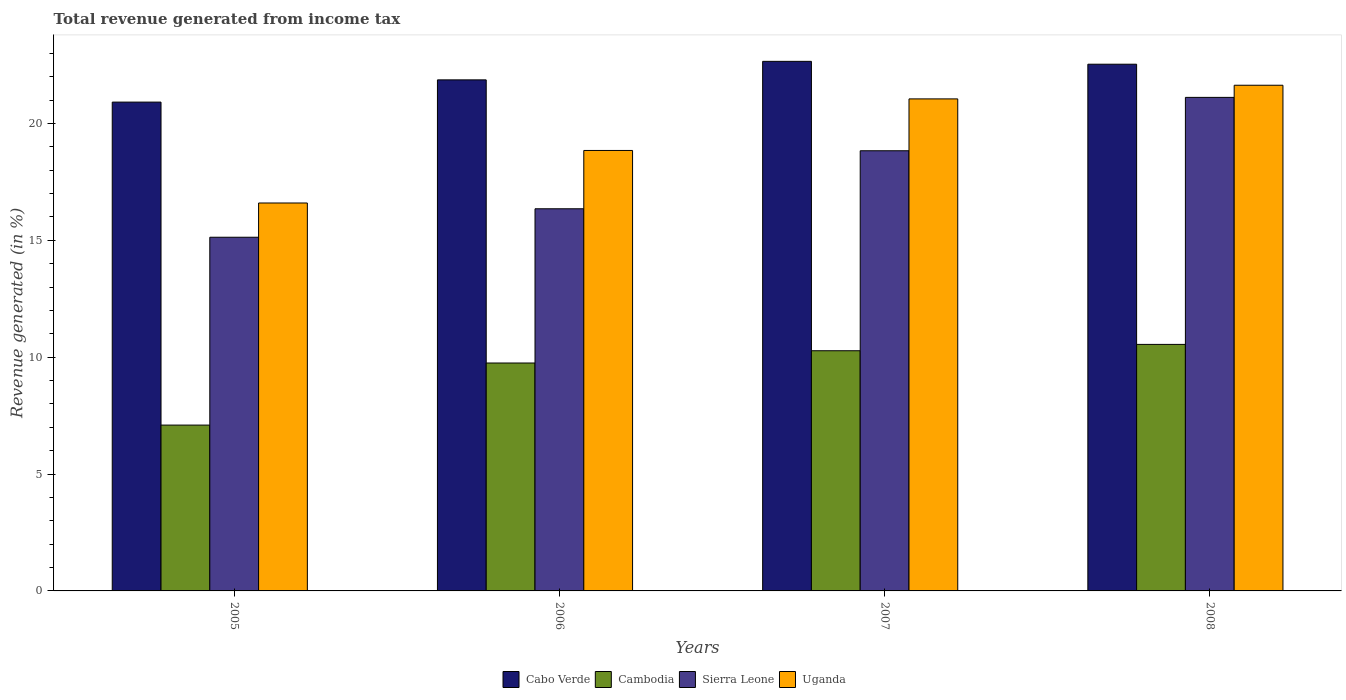How many different coloured bars are there?
Provide a succinct answer. 4. How many groups of bars are there?
Ensure brevity in your answer.  4. Are the number of bars per tick equal to the number of legend labels?
Your answer should be very brief. Yes. How many bars are there on the 1st tick from the right?
Provide a short and direct response. 4. What is the label of the 3rd group of bars from the left?
Make the answer very short. 2007. What is the total revenue generated in Uganda in 2008?
Provide a succinct answer. 21.63. Across all years, what is the maximum total revenue generated in Uganda?
Provide a short and direct response. 21.63. Across all years, what is the minimum total revenue generated in Sierra Leone?
Offer a very short reply. 15.13. What is the total total revenue generated in Cambodia in the graph?
Your answer should be compact. 37.67. What is the difference between the total revenue generated in Cambodia in 2005 and that in 2007?
Your answer should be compact. -3.18. What is the difference between the total revenue generated in Cambodia in 2008 and the total revenue generated in Sierra Leone in 2005?
Offer a very short reply. -4.58. What is the average total revenue generated in Uganda per year?
Ensure brevity in your answer.  19.53. In the year 2007, what is the difference between the total revenue generated in Uganda and total revenue generated in Cabo Verde?
Give a very brief answer. -1.61. In how many years, is the total revenue generated in Cabo Verde greater than 22 %?
Keep it short and to the point. 2. What is the ratio of the total revenue generated in Cabo Verde in 2007 to that in 2008?
Keep it short and to the point. 1.01. Is the total revenue generated in Sierra Leone in 2005 less than that in 2008?
Make the answer very short. Yes. What is the difference between the highest and the second highest total revenue generated in Cabo Verde?
Ensure brevity in your answer.  0.12. What is the difference between the highest and the lowest total revenue generated in Sierra Leone?
Your answer should be very brief. 5.98. In how many years, is the total revenue generated in Cabo Verde greater than the average total revenue generated in Cabo Verde taken over all years?
Ensure brevity in your answer.  2. Is it the case that in every year, the sum of the total revenue generated in Sierra Leone and total revenue generated in Cambodia is greater than the sum of total revenue generated in Cabo Verde and total revenue generated in Uganda?
Keep it short and to the point. No. What does the 1st bar from the left in 2005 represents?
Make the answer very short. Cabo Verde. What does the 2nd bar from the right in 2007 represents?
Give a very brief answer. Sierra Leone. How many years are there in the graph?
Give a very brief answer. 4. What is the difference between two consecutive major ticks on the Y-axis?
Make the answer very short. 5. Where does the legend appear in the graph?
Offer a terse response. Bottom center. How many legend labels are there?
Your answer should be compact. 4. How are the legend labels stacked?
Offer a very short reply. Horizontal. What is the title of the graph?
Offer a terse response. Total revenue generated from income tax. What is the label or title of the X-axis?
Give a very brief answer. Years. What is the label or title of the Y-axis?
Your answer should be compact. Revenue generated (in %). What is the Revenue generated (in %) of Cabo Verde in 2005?
Your response must be concise. 20.91. What is the Revenue generated (in %) in Cambodia in 2005?
Provide a short and direct response. 7.09. What is the Revenue generated (in %) of Sierra Leone in 2005?
Your answer should be compact. 15.13. What is the Revenue generated (in %) in Uganda in 2005?
Offer a very short reply. 16.6. What is the Revenue generated (in %) of Cabo Verde in 2006?
Keep it short and to the point. 21.86. What is the Revenue generated (in %) of Cambodia in 2006?
Offer a very short reply. 9.75. What is the Revenue generated (in %) of Sierra Leone in 2006?
Your response must be concise. 16.35. What is the Revenue generated (in %) of Uganda in 2006?
Keep it short and to the point. 18.84. What is the Revenue generated (in %) of Cabo Verde in 2007?
Offer a terse response. 22.66. What is the Revenue generated (in %) of Cambodia in 2007?
Offer a terse response. 10.28. What is the Revenue generated (in %) in Sierra Leone in 2007?
Give a very brief answer. 18.83. What is the Revenue generated (in %) in Uganda in 2007?
Ensure brevity in your answer.  21.05. What is the Revenue generated (in %) in Cabo Verde in 2008?
Offer a very short reply. 22.53. What is the Revenue generated (in %) in Cambodia in 2008?
Ensure brevity in your answer.  10.55. What is the Revenue generated (in %) of Sierra Leone in 2008?
Your answer should be compact. 21.11. What is the Revenue generated (in %) of Uganda in 2008?
Your answer should be very brief. 21.63. Across all years, what is the maximum Revenue generated (in %) in Cabo Verde?
Ensure brevity in your answer.  22.66. Across all years, what is the maximum Revenue generated (in %) of Cambodia?
Offer a terse response. 10.55. Across all years, what is the maximum Revenue generated (in %) in Sierra Leone?
Offer a terse response. 21.11. Across all years, what is the maximum Revenue generated (in %) in Uganda?
Offer a terse response. 21.63. Across all years, what is the minimum Revenue generated (in %) in Cabo Verde?
Provide a short and direct response. 20.91. Across all years, what is the minimum Revenue generated (in %) of Cambodia?
Ensure brevity in your answer.  7.09. Across all years, what is the minimum Revenue generated (in %) of Sierra Leone?
Ensure brevity in your answer.  15.13. Across all years, what is the minimum Revenue generated (in %) in Uganda?
Ensure brevity in your answer.  16.6. What is the total Revenue generated (in %) in Cabo Verde in the graph?
Ensure brevity in your answer.  87.97. What is the total Revenue generated (in %) in Cambodia in the graph?
Offer a terse response. 37.67. What is the total Revenue generated (in %) of Sierra Leone in the graph?
Your response must be concise. 71.43. What is the total Revenue generated (in %) of Uganda in the graph?
Provide a succinct answer. 78.12. What is the difference between the Revenue generated (in %) in Cabo Verde in 2005 and that in 2006?
Your answer should be compact. -0.95. What is the difference between the Revenue generated (in %) in Cambodia in 2005 and that in 2006?
Ensure brevity in your answer.  -2.66. What is the difference between the Revenue generated (in %) in Sierra Leone in 2005 and that in 2006?
Your answer should be compact. -1.22. What is the difference between the Revenue generated (in %) of Uganda in 2005 and that in 2006?
Provide a succinct answer. -2.25. What is the difference between the Revenue generated (in %) in Cabo Verde in 2005 and that in 2007?
Provide a succinct answer. -1.74. What is the difference between the Revenue generated (in %) of Cambodia in 2005 and that in 2007?
Make the answer very short. -3.18. What is the difference between the Revenue generated (in %) of Sierra Leone in 2005 and that in 2007?
Your answer should be very brief. -3.7. What is the difference between the Revenue generated (in %) in Uganda in 2005 and that in 2007?
Provide a succinct answer. -4.45. What is the difference between the Revenue generated (in %) of Cabo Verde in 2005 and that in 2008?
Your answer should be very brief. -1.62. What is the difference between the Revenue generated (in %) in Cambodia in 2005 and that in 2008?
Provide a succinct answer. -3.45. What is the difference between the Revenue generated (in %) of Sierra Leone in 2005 and that in 2008?
Keep it short and to the point. -5.98. What is the difference between the Revenue generated (in %) in Uganda in 2005 and that in 2008?
Give a very brief answer. -5.04. What is the difference between the Revenue generated (in %) of Cabo Verde in 2006 and that in 2007?
Offer a terse response. -0.79. What is the difference between the Revenue generated (in %) of Cambodia in 2006 and that in 2007?
Ensure brevity in your answer.  -0.52. What is the difference between the Revenue generated (in %) in Sierra Leone in 2006 and that in 2007?
Your answer should be compact. -2.48. What is the difference between the Revenue generated (in %) of Uganda in 2006 and that in 2007?
Your answer should be compact. -2.21. What is the difference between the Revenue generated (in %) of Cabo Verde in 2006 and that in 2008?
Your answer should be very brief. -0.67. What is the difference between the Revenue generated (in %) in Cambodia in 2006 and that in 2008?
Your answer should be very brief. -0.8. What is the difference between the Revenue generated (in %) in Sierra Leone in 2006 and that in 2008?
Provide a succinct answer. -4.77. What is the difference between the Revenue generated (in %) of Uganda in 2006 and that in 2008?
Your answer should be very brief. -2.79. What is the difference between the Revenue generated (in %) in Cabo Verde in 2007 and that in 2008?
Give a very brief answer. 0.12. What is the difference between the Revenue generated (in %) in Cambodia in 2007 and that in 2008?
Your response must be concise. -0.27. What is the difference between the Revenue generated (in %) of Sierra Leone in 2007 and that in 2008?
Provide a short and direct response. -2.28. What is the difference between the Revenue generated (in %) of Uganda in 2007 and that in 2008?
Provide a short and direct response. -0.58. What is the difference between the Revenue generated (in %) of Cabo Verde in 2005 and the Revenue generated (in %) of Cambodia in 2006?
Your answer should be very brief. 11.16. What is the difference between the Revenue generated (in %) in Cabo Verde in 2005 and the Revenue generated (in %) in Sierra Leone in 2006?
Provide a succinct answer. 4.56. What is the difference between the Revenue generated (in %) of Cabo Verde in 2005 and the Revenue generated (in %) of Uganda in 2006?
Provide a short and direct response. 2.07. What is the difference between the Revenue generated (in %) in Cambodia in 2005 and the Revenue generated (in %) in Sierra Leone in 2006?
Offer a terse response. -9.25. What is the difference between the Revenue generated (in %) in Cambodia in 2005 and the Revenue generated (in %) in Uganda in 2006?
Your answer should be compact. -11.75. What is the difference between the Revenue generated (in %) of Sierra Leone in 2005 and the Revenue generated (in %) of Uganda in 2006?
Ensure brevity in your answer.  -3.71. What is the difference between the Revenue generated (in %) in Cabo Verde in 2005 and the Revenue generated (in %) in Cambodia in 2007?
Provide a succinct answer. 10.64. What is the difference between the Revenue generated (in %) in Cabo Verde in 2005 and the Revenue generated (in %) in Sierra Leone in 2007?
Provide a short and direct response. 2.08. What is the difference between the Revenue generated (in %) in Cabo Verde in 2005 and the Revenue generated (in %) in Uganda in 2007?
Give a very brief answer. -0.14. What is the difference between the Revenue generated (in %) of Cambodia in 2005 and the Revenue generated (in %) of Sierra Leone in 2007?
Ensure brevity in your answer.  -11.74. What is the difference between the Revenue generated (in %) in Cambodia in 2005 and the Revenue generated (in %) in Uganda in 2007?
Give a very brief answer. -13.96. What is the difference between the Revenue generated (in %) in Sierra Leone in 2005 and the Revenue generated (in %) in Uganda in 2007?
Your answer should be compact. -5.92. What is the difference between the Revenue generated (in %) in Cabo Verde in 2005 and the Revenue generated (in %) in Cambodia in 2008?
Give a very brief answer. 10.37. What is the difference between the Revenue generated (in %) of Cabo Verde in 2005 and the Revenue generated (in %) of Sierra Leone in 2008?
Keep it short and to the point. -0.2. What is the difference between the Revenue generated (in %) in Cabo Verde in 2005 and the Revenue generated (in %) in Uganda in 2008?
Your answer should be very brief. -0.72. What is the difference between the Revenue generated (in %) in Cambodia in 2005 and the Revenue generated (in %) in Sierra Leone in 2008?
Keep it short and to the point. -14.02. What is the difference between the Revenue generated (in %) in Cambodia in 2005 and the Revenue generated (in %) in Uganda in 2008?
Provide a succinct answer. -14.54. What is the difference between the Revenue generated (in %) in Sierra Leone in 2005 and the Revenue generated (in %) in Uganda in 2008?
Your response must be concise. -6.5. What is the difference between the Revenue generated (in %) of Cabo Verde in 2006 and the Revenue generated (in %) of Cambodia in 2007?
Provide a short and direct response. 11.59. What is the difference between the Revenue generated (in %) of Cabo Verde in 2006 and the Revenue generated (in %) of Sierra Leone in 2007?
Keep it short and to the point. 3.03. What is the difference between the Revenue generated (in %) of Cabo Verde in 2006 and the Revenue generated (in %) of Uganda in 2007?
Provide a short and direct response. 0.81. What is the difference between the Revenue generated (in %) in Cambodia in 2006 and the Revenue generated (in %) in Sierra Leone in 2007?
Ensure brevity in your answer.  -9.08. What is the difference between the Revenue generated (in %) of Cambodia in 2006 and the Revenue generated (in %) of Uganda in 2007?
Make the answer very short. -11.3. What is the difference between the Revenue generated (in %) of Sierra Leone in 2006 and the Revenue generated (in %) of Uganda in 2007?
Provide a succinct answer. -4.7. What is the difference between the Revenue generated (in %) in Cabo Verde in 2006 and the Revenue generated (in %) in Cambodia in 2008?
Your response must be concise. 11.32. What is the difference between the Revenue generated (in %) of Cabo Verde in 2006 and the Revenue generated (in %) of Sierra Leone in 2008?
Give a very brief answer. 0.75. What is the difference between the Revenue generated (in %) in Cabo Verde in 2006 and the Revenue generated (in %) in Uganda in 2008?
Provide a succinct answer. 0.23. What is the difference between the Revenue generated (in %) in Cambodia in 2006 and the Revenue generated (in %) in Sierra Leone in 2008?
Your answer should be compact. -11.36. What is the difference between the Revenue generated (in %) in Cambodia in 2006 and the Revenue generated (in %) in Uganda in 2008?
Offer a very short reply. -11.88. What is the difference between the Revenue generated (in %) in Sierra Leone in 2006 and the Revenue generated (in %) in Uganda in 2008?
Provide a short and direct response. -5.28. What is the difference between the Revenue generated (in %) in Cabo Verde in 2007 and the Revenue generated (in %) in Cambodia in 2008?
Give a very brief answer. 12.11. What is the difference between the Revenue generated (in %) in Cabo Verde in 2007 and the Revenue generated (in %) in Sierra Leone in 2008?
Ensure brevity in your answer.  1.54. What is the difference between the Revenue generated (in %) in Cabo Verde in 2007 and the Revenue generated (in %) in Uganda in 2008?
Give a very brief answer. 1.02. What is the difference between the Revenue generated (in %) in Cambodia in 2007 and the Revenue generated (in %) in Sierra Leone in 2008?
Provide a succinct answer. -10.84. What is the difference between the Revenue generated (in %) of Cambodia in 2007 and the Revenue generated (in %) of Uganda in 2008?
Your answer should be very brief. -11.36. What is the difference between the Revenue generated (in %) of Sierra Leone in 2007 and the Revenue generated (in %) of Uganda in 2008?
Make the answer very short. -2.8. What is the average Revenue generated (in %) in Cabo Verde per year?
Keep it short and to the point. 21.99. What is the average Revenue generated (in %) of Cambodia per year?
Ensure brevity in your answer.  9.42. What is the average Revenue generated (in %) in Sierra Leone per year?
Give a very brief answer. 17.86. What is the average Revenue generated (in %) in Uganda per year?
Keep it short and to the point. 19.53. In the year 2005, what is the difference between the Revenue generated (in %) in Cabo Verde and Revenue generated (in %) in Cambodia?
Offer a terse response. 13.82. In the year 2005, what is the difference between the Revenue generated (in %) in Cabo Verde and Revenue generated (in %) in Sierra Leone?
Give a very brief answer. 5.78. In the year 2005, what is the difference between the Revenue generated (in %) of Cabo Verde and Revenue generated (in %) of Uganda?
Give a very brief answer. 4.32. In the year 2005, what is the difference between the Revenue generated (in %) in Cambodia and Revenue generated (in %) in Sierra Leone?
Your answer should be very brief. -8.04. In the year 2005, what is the difference between the Revenue generated (in %) in Cambodia and Revenue generated (in %) in Uganda?
Give a very brief answer. -9.5. In the year 2005, what is the difference between the Revenue generated (in %) in Sierra Leone and Revenue generated (in %) in Uganda?
Your response must be concise. -1.46. In the year 2006, what is the difference between the Revenue generated (in %) in Cabo Verde and Revenue generated (in %) in Cambodia?
Provide a short and direct response. 12.11. In the year 2006, what is the difference between the Revenue generated (in %) of Cabo Verde and Revenue generated (in %) of Sierra Leone?
Your answer should be very brief. 5.51. In the year 2006, what is the difference between the Revenue generated (in %) in Cabo Verde and Revenue generated (in %) in Uganda?
Your answer should be very brief. 3.02. In the year 2006, what is the difference between the Revenue generated (in %) of Cambodia and Revenue generated (in %) of Sierra Leone?
Keep it short and to the point. -6.6. In the year 2006, what is the difference between the Revenue generated (in %) of Cambodia and Revenue generated (in %) of Uganda?
Keep it short and to the point. -9.09. In the year 2006, what is the difference between the Revenue generated (in %) of Sierra Leone and Revenue generated (in %) of Uganda?
Offer a terse response. -2.49. In the year 2007, what is the difference between the Revenue generated (in %) in Cabo Verde and Revenue generated (in %) in Cambodia?
Offer a very short reply. 12.38. In the year 2007, what is the difference between the Revenue generated (in %) in Cabo Verde and Revenue generated (in %) in Sierra Leone?
Offer a terse response. 3.83. In the year 2007, what is the difference between the Revenue generated (in %) in Cabo Verde and Revenue generated (in %) in Uganda?
Offer a terse response. 1.61. In the year 2007, what is the difference between the Revenue generated (in %) in Cambodia and Revenue generated (in %) in Sierra Leone?
Your answer should be compact. -8.56. In the year 2007, what is the difference between the Revenue generated (in %) in Cambodia and Revenue generated (in %) in Uganda?
Your response must be concise. -10.77. In the year 2007, what is the difference between the Revenue generated (in %) in Sierra Leone and Revenue generated (in %) in Uganda?
Offer a very short reply. -2.22. In the year 2008, what is the difference between the Revenue generated (in %) of Cabo Verde and Revenue generated (in %) of Cambodia?
Your answer should be compact. 11.99. In the year 2008, what is the difference between the Revenue generated (in %) in Cabo Verde and Revenue generated (in %) in Sierra Leone?
Your answer should be compact. 1.42. In the year 2008, what is the difference between the Revenue generated (in %) of Cabo Verde and Revenue generated (in %) of Uganda?
Offer a very short reply. 0.9. In the year 2008, what is the difference between the Revenue generated (in %) of Cambodia and Revenue generated (in %) of Sierra Leone?
Provide a short and direct response. -10.57. In the year 2008, what is the difference between the Revenue generated (in %) in Cambodia and Revenue generated (in %) in Uganda?
Offer a terse response. -11.09. In the year 2008, what is the difference between the Revenue generated (in %) of Sierra Leone and Revenue generated (in %) of Uganda?
Your response must be concise. -0.52. What is the ratio of the Revenue generated (in %) in Cabo Verde in 2005 to that in 2006?
Ensure brevity in your answer.  0.96. What is the ratio of the Revenue generated (in %) in Cambodia in 2005 to that in 2006?
Your answer should be very brief. 0.73. What is the ratio of the Revenue generated (in %) of Sierra Leone in 2005 to that in 2006?
Give a very brief answer. 0.93. What is the ratio of the Revenue generated (in %) of Uganda in 2005 to that in 2006?
Your answer should be very brief. 0.88. What is the ratio of the Revenue generated (in %) of Cambodia in 2005 to that in 2007?
Offer a very short reply. 0.69. What is the ratio of the Revenue generated (in %) of Sierra Leone in 2005 to that in 2007?
Provide a short and direct response. 0.8. What is the ratio of the Revenue generated (in %) of Uganda in 2005 to that in 2007?
Provide a short and direct response. 0.79. What is the ratio of the Revenue generated (in %) of Cabo Verde in 2005 to that in 2008?
Your answer should be compact. 0.93. What is the ratio of the Revenue generated (in %) of Cambodia in 2005 to that in 2008?
Your answer should be compact. 0.67. What is the ratio of the Revenue generated (in %) in Sierra Leone in 2005 to that in 2008?
Make the answer very short. 0.72. What is the ratio of the Revenue generated (in %) of Uganda in 2005 to that in 2008?
Provide a succinct answer. 0.77. What is the ratio of the Revenue generated (in %) of Cabo Verde in 2006 to that in 2007?
Give a very brief answer. 0.96. What is the ratio of the Revenue generated (in %) in Cambodia in 2006 to that in 2007?
Your answer should be very brief. 0.95. What is the ratio of the Revenue generated (in %) of Sierra Leone in 2006 to that in 2007?
Your answer should be compact. 0.87. What is the ratio of the Revenue generated (in %) of Uganda in 2006 to that in 2007?
Give a very brief answer. 0.9. What is the ratio of the Revenue generated (in %) in Cabo Verde in 2006 to that in 2008?
Your answer should be very brief. 0.97. What is the ratio of the Revenue generated (in %) in Cambodia in 2006 to that in 2008?
Keep it short and to the point. 0.92. What is the ratio of the Revenue generated (in %) in Sierra Leone in 2006 to that in 2008?
Ensure brevity in your answer.  0.77. What is the ratio of the Revenue generated (in %) in Uganda in 2006 to that in 2008?
Your response must be concise. 0.87. What is the ratio of the Revenue generated (in %) in Cabo Verde in 2007 to that in 2008?
Keep it short and to the point. 1.01. What is the ratio of the Revenue generated (in %) in Cambodia in 2007 to that in 2008?
Offer a terse response. 0.97. What is the ratio of the Revenue generated (in %) in Sierra Leone in 2007 to that in 2008?
Offer a terse response. 0.89. What is the ratio of the Revenue generated (in %) of Uganda in 2007 to that in 2008?
Provide a succinct answer. 0.97. What is the difference between the highest and the second highest Revenue generated (in %) of Cabo Verde?
Make the answer very short. 0.12. What is the difference between the highest and the second highest Revenue generated (in %) of Cambodia?
Keep it short and to the point. 0.27. What is the difference between the highest and the second highest Revenue generated (in %) of Sierra Leone?
Your answer should be very brief. 2.28. What is the difference between the highest and the second highest Revenue generated (in %) of Uganda?
Provide a succinct answer. 0.58. What is the difference between the highest and the lowest Revenue generated (in %) of Cabo Verde?
Your answer should be compact. 1.74. What is the difference between the highest and the lowest Revenue generated (in %) in Cambodia?
Provide a short and direct response. 3.45. What is the difference between the highest and the lowest Revenue generated (in %) in Sierra Leone?
Provide a succinct answer. 5.98. What is the difference between the highest and the lowest Revenue generated (in %) of Uganda?
Offer a terse response. 5.04. 